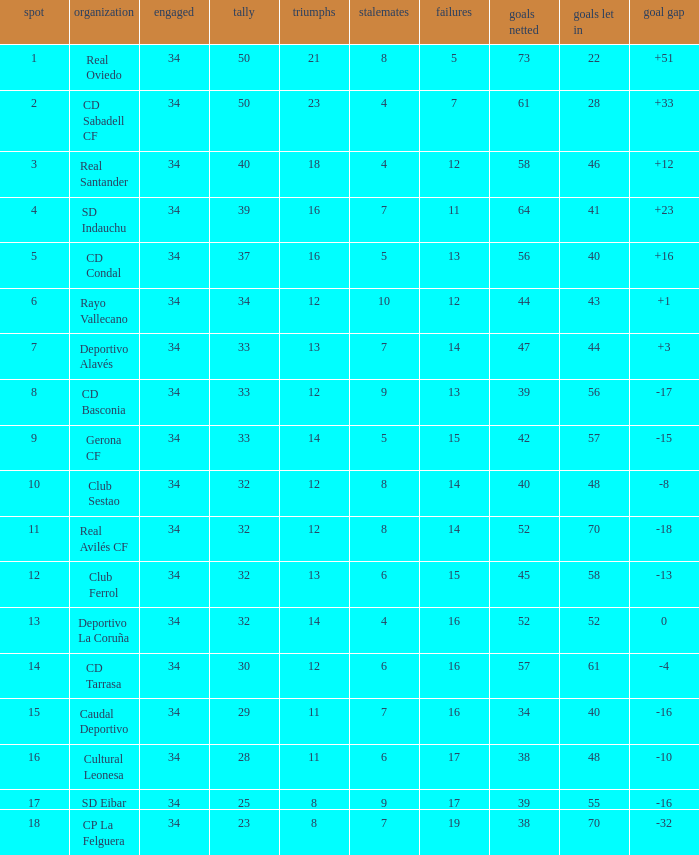Which player has less than 7 draws, fewer than 61 goals for, less than 48 goals against, and a position of 5? 34.0. 